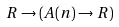<formula> <loc_0><loc_0><loc_500><loc_500>R \to ( A ( n ) \to R )</formula> 